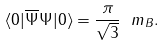Convert formula to latex. <formula><loc_0><loc_0><loc_500><loc_500>\langle 0 | \overline { \Psi } \Psi | 0 \rangle = \frac { \pi } { \sqrt { 3 } } \ m _ { B } .</formula> 